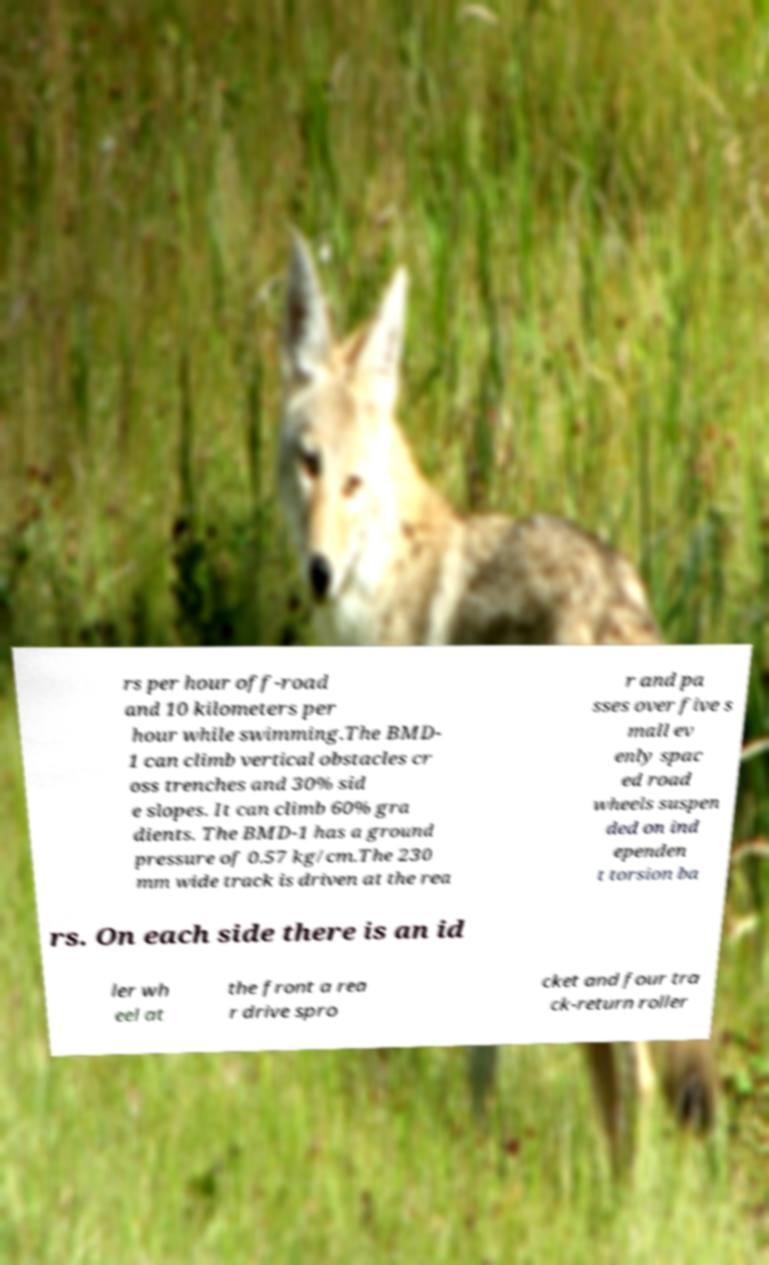For documentation purposes, I need the text within this image transcribed. Could you provide that? rs per hour off-road and 10 kilometers per hour while swimming.The BMD- 1 can climb vertical obstacles cr oss trenches and 30% sid e slopes. It can climb 60% gra dients. The BMD-1 has a ground pressure of 0.57 kg/cm.The 230 mm wide track is driven at the rea r and pa sses over five s mall ev enly spac ed road wheels suspen ded on ind ependen t torsion ba rs. On each side there is an id ler wh eel at the front a rea r drive spro cket and four tra ck-return roller 